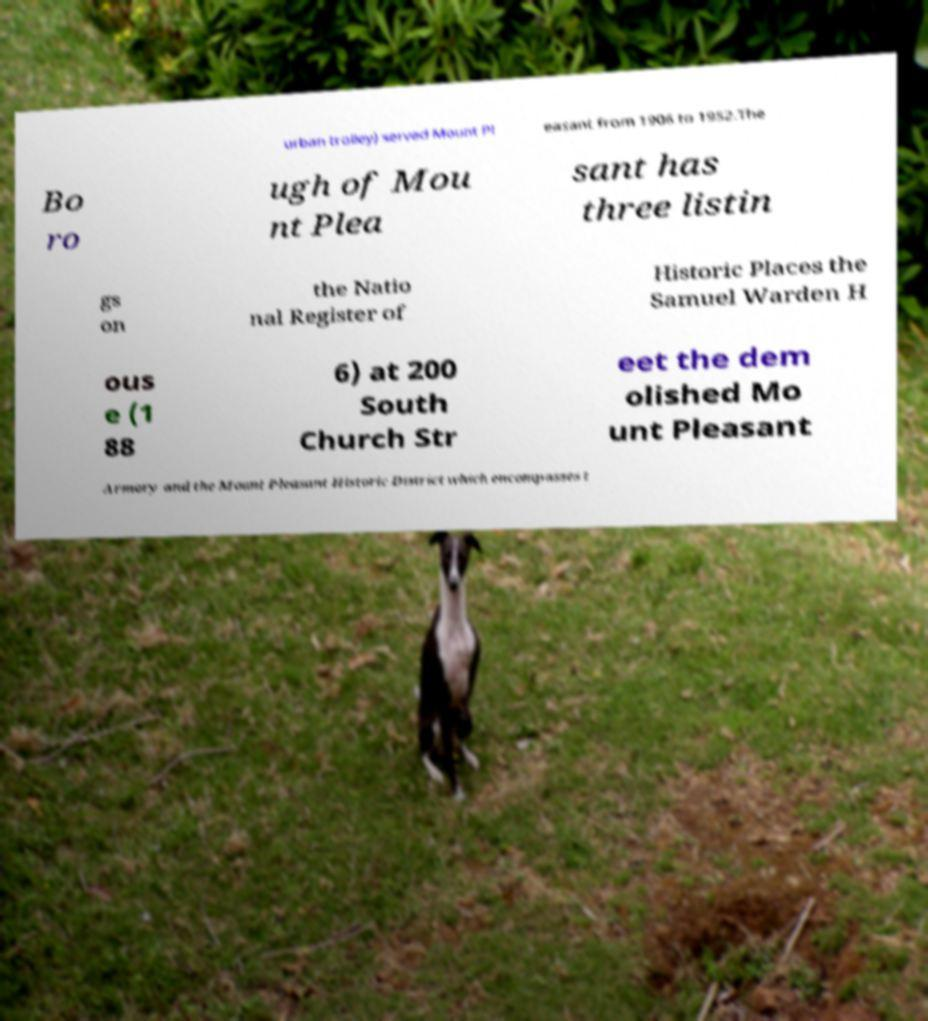I need the written content from this picture converted into text. Can you do that? urban trolley) served Mount Pl easant from 1906 to 1952.The Bo ro ugh of Mou nt Plea sant has three listin gs on the Natio nal Register of Historic Places the Samuel Warden H ous e (1 88 6) at 200 South Church Str eet the dem olished Mo unt Pleasant Armory and the Mount Pleasant Historic District which encompasses t 